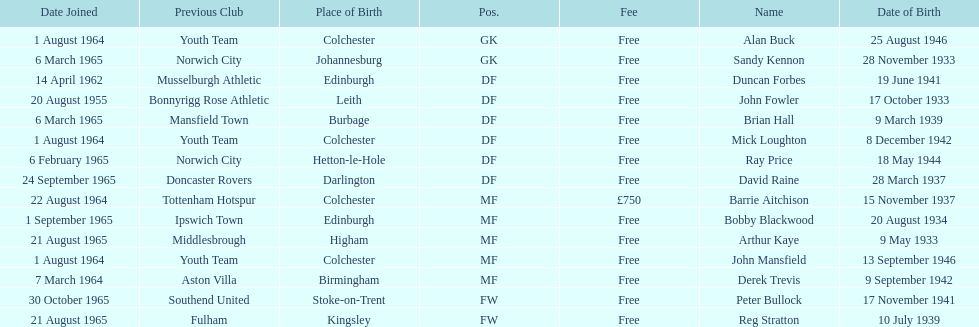What is the date of the lst player that joined? 20 August 1955. 